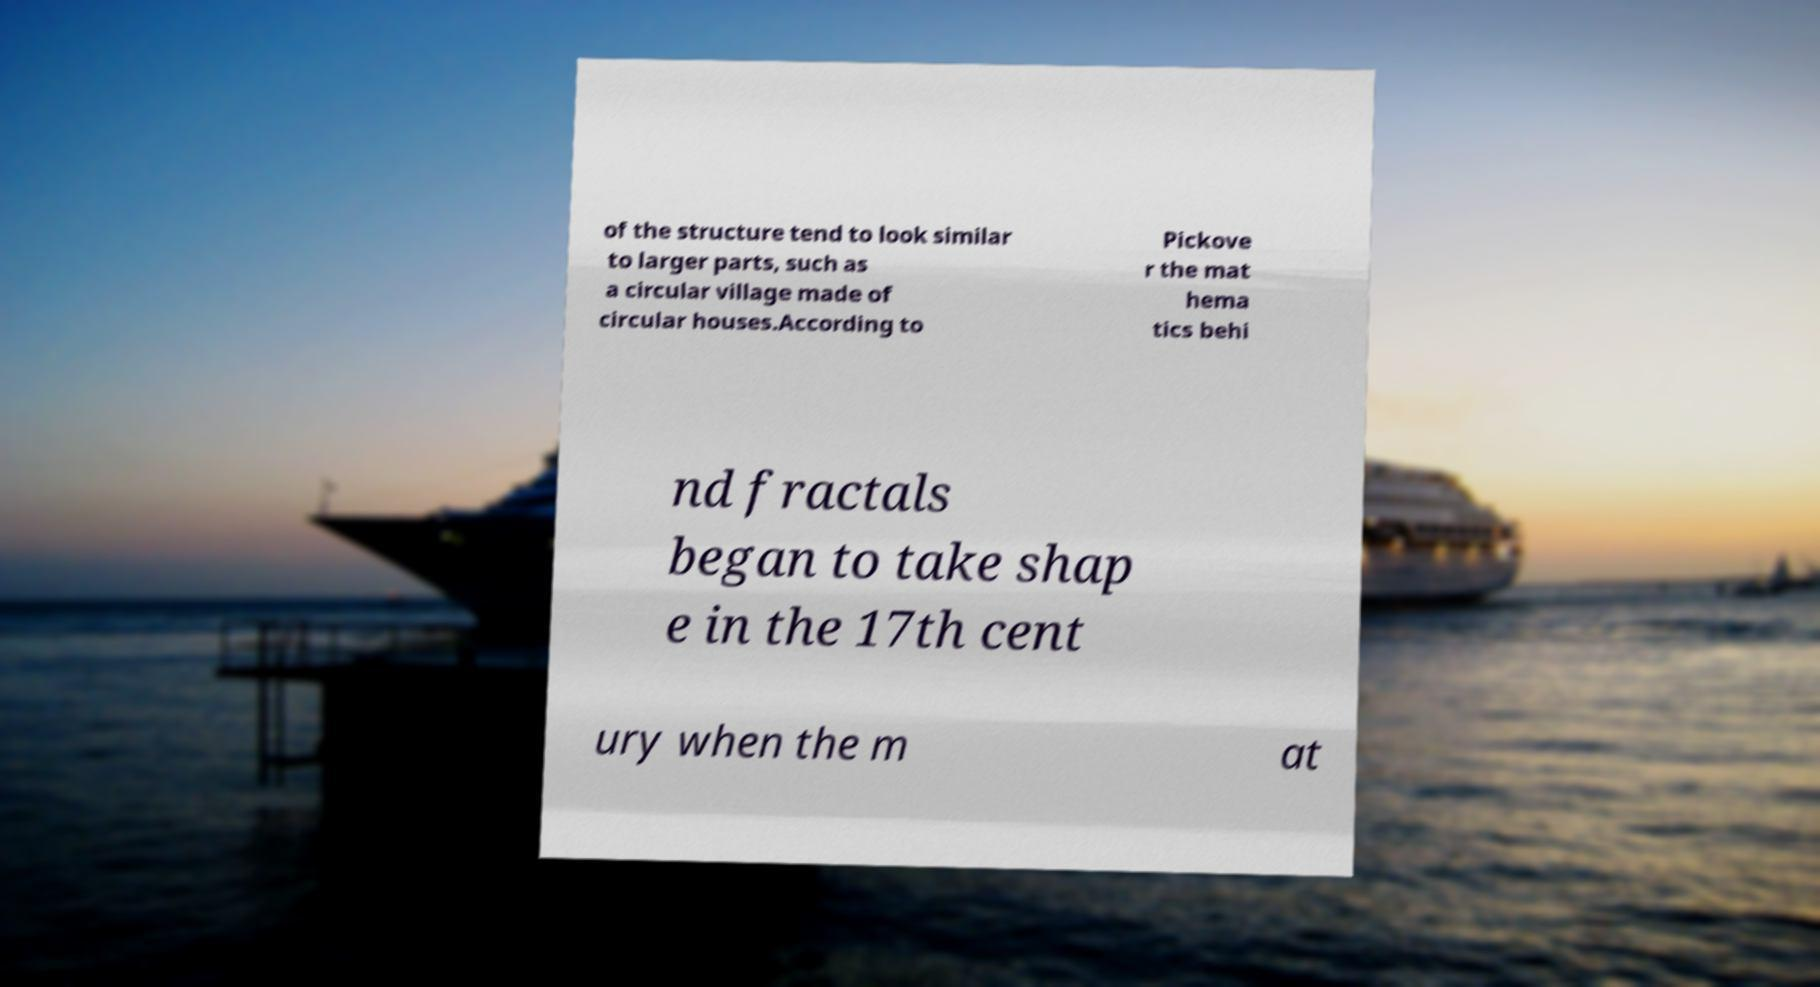What messages or text are displayed in this image? I need them in a readable, typed format. of the structure tend to look similar to larger parts, such as a circular village made of circular houses.According to Pickove r the mat hema tics behi nd fractals began to take shap e in the 17th cent ury when the m at 